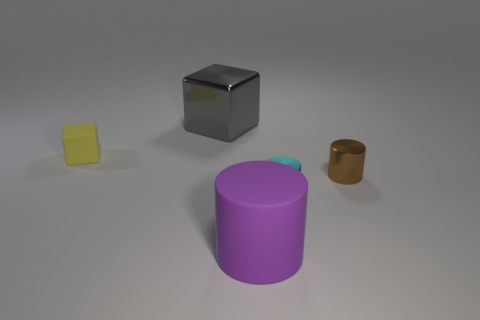There is a block that is made of the same material as the small brown cylinder; what color is it?
Provide a succinct answer. Gray. How many cylinders are made of the same material as the gray block?
Provide a short and direct response. 2. There is a tiny cylinder to the left of the brown thing; is it the same color as the large cylinder?
Give a very brief answer. No. How many metallic objects have the same shape as the tiny yellow matte object?
Your answer should be very brief. 1. Are there an equal number of large gray cubes that are in front of the tiny brown cylinder and green matte things?
Offer a very short reply. Yes. There is a object that is the same size as the rubber cylinder; what is its color?
Offer a terse response. Gray. Is there a big object that has the same shape as the small yellow object?
Your answer should be very brief. Yes. There is a large thing behind the small yellow matte cube on the left side of the big thing that is in front of the small yellow matte block; what is its material?
Your response must be concise. Metal. How many other things are there of the same size as the cyan cylinder?
Provide a short and direct response. 2. The rubber cube has what color?
Ensure brevity in your answer.  Yellow. 